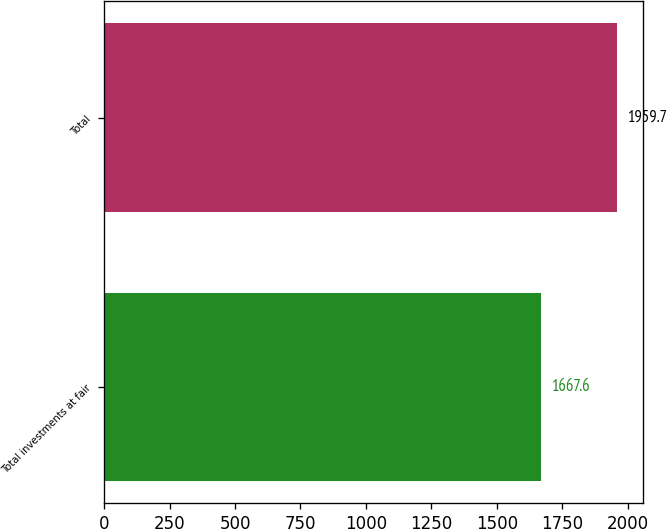<chart> <loc_0><loc_0><loc_500><loc_500><bar_chart><fcel>Total investments at fair<fcel>Total<nl><fcel>1667.6<fcel>1959.7<nl></chart> 